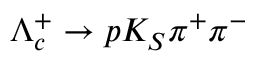<formula> <loc_0><loc_0><loc_500><loc_500>\Lambda _ { c } ^ { + } \to p K _ { S } \pi ^ { + } \pi ^ { - }</formula> 